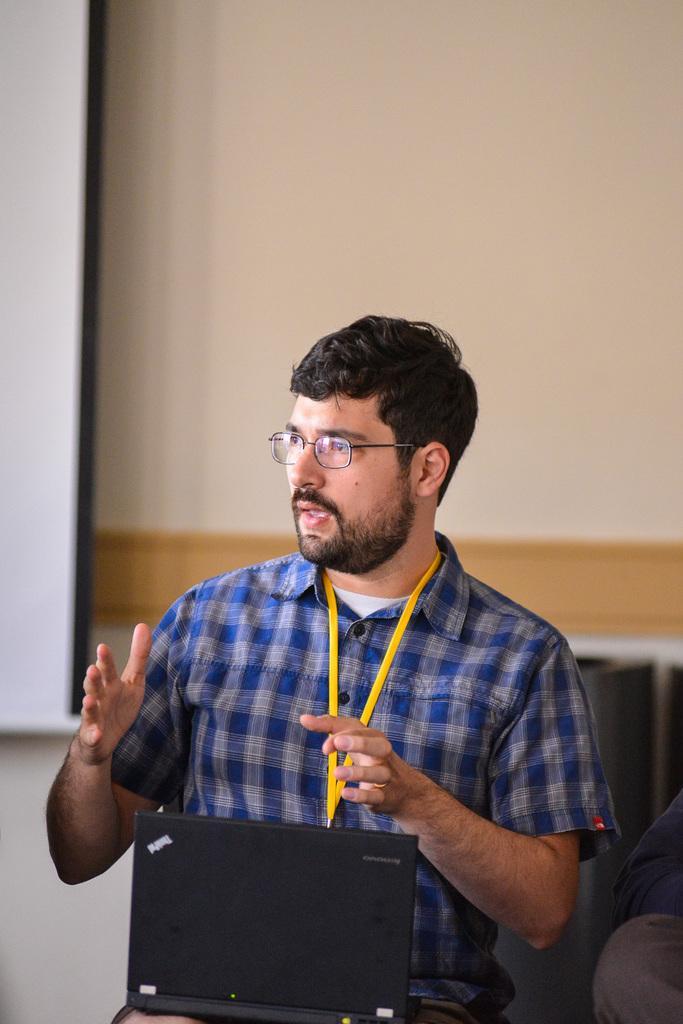Can you describe this image briefly? There is a man sitting and holding laptop and talking and wore tag, beside him we can see a person. In the background we can see wall and banner. 